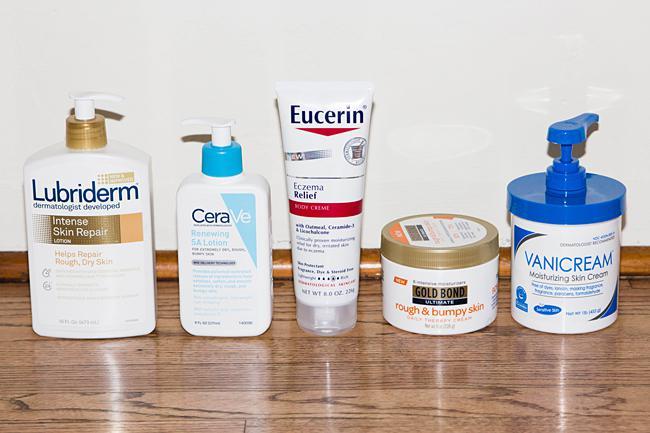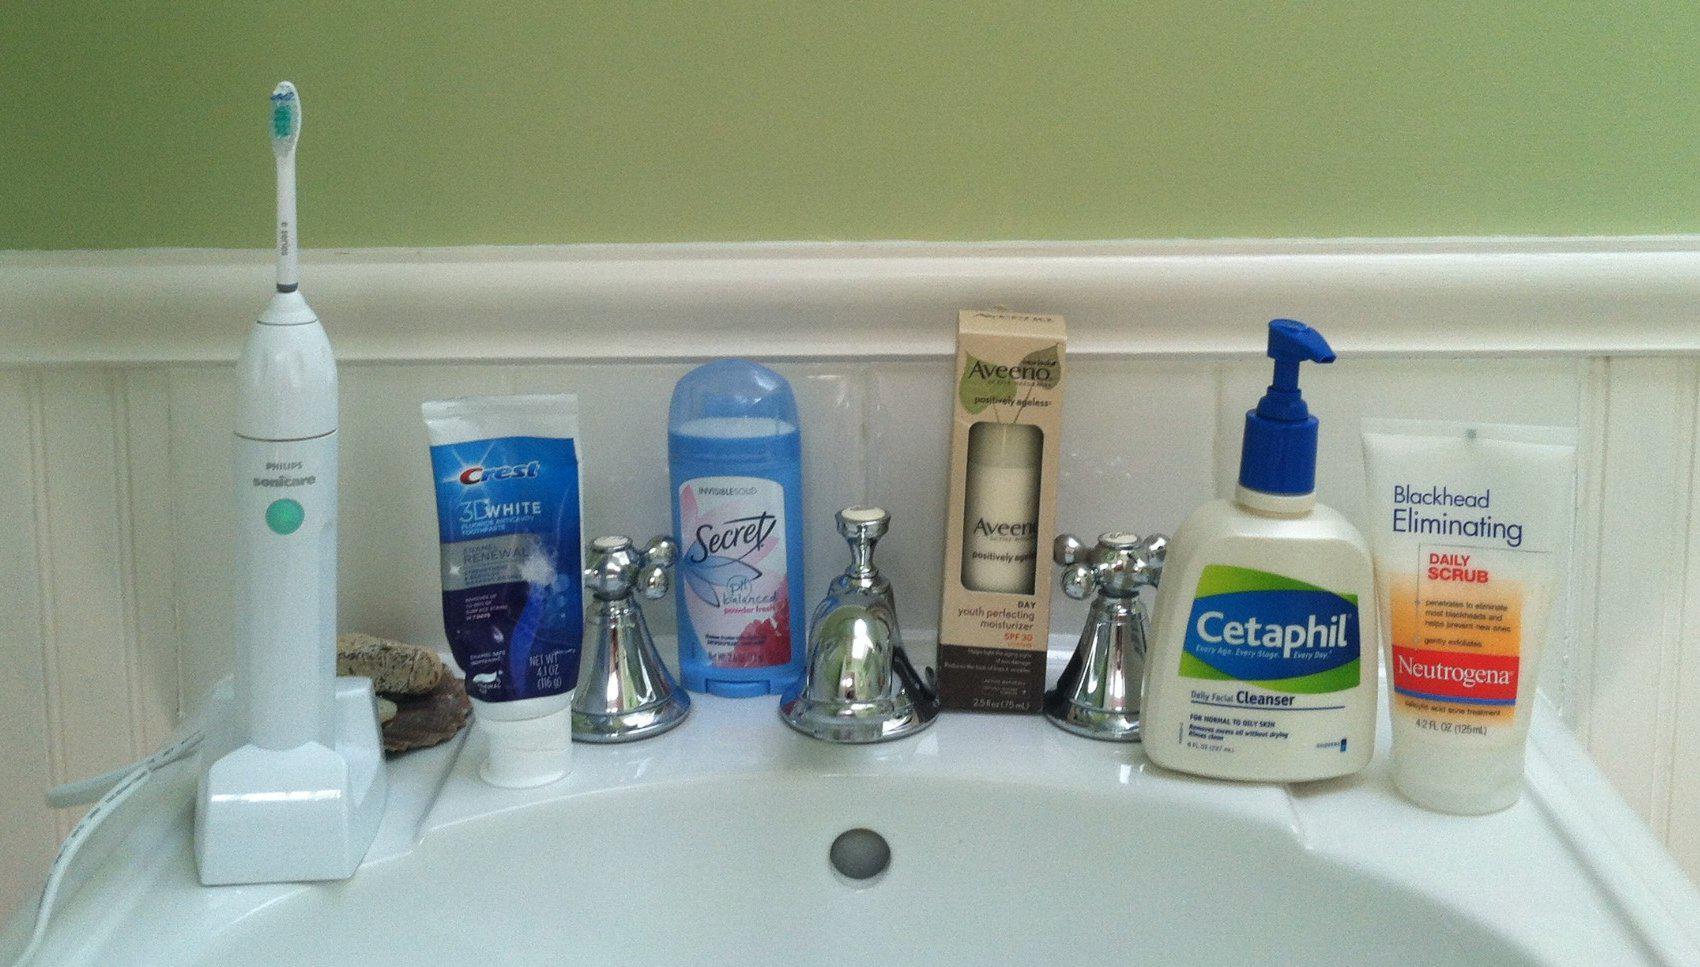The first image is the image on the left, the second image is the image on the right. For the images displayed, is the sentence "In each image, at least five different personal care products are arranged in a row so that all labels are showing." factually correct? Answer yes or no. Yes. 